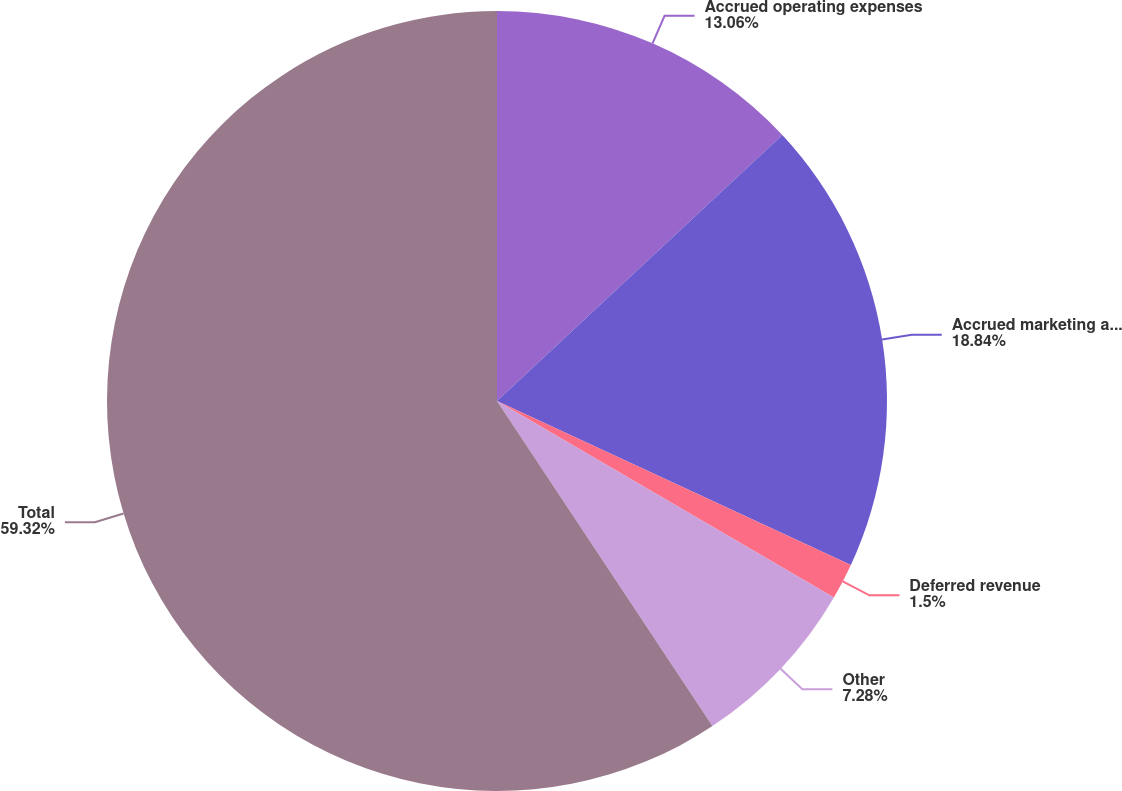Convert chart to OTSL. <chart><loc_0><loc_0><loc_500><loc_500><pie_chart><fcel>Accrued operating expenses<fcel>Accrued marketing and product<fcel>Deferred revenue<fcel>Other<fcel>Total<nl><fcel>13.06%<fcel>18.84%<fcel>1.5%<fcel>7.28%<fcel>59.31%<nl></chart> 